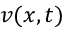Convert formula to latex. <formula><loc_0><loc_0><loc_500><loc_500>v ( x , t )</formula> 